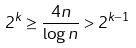<formula> <loc_0><loc_0><loc_500><loc_500>2 ^ { k } \geq \frac { 4 n } { \log n } > 2 ^ { k - 1 }</formula> 